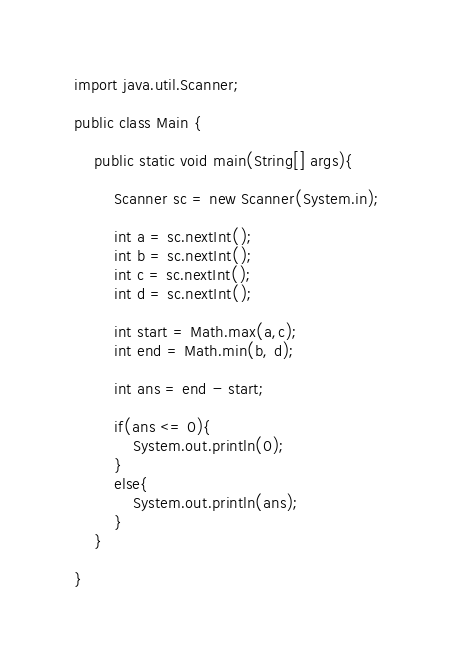Convert code to text. <code><loc_0><loc_0><loc_500><loc_500><_Java_>import java.util.Scanner;

public class Main {

	public static void main(String[] args){
		
		Scanner sc = new Scanner(System.in);
		
		int a = sc.nextInt();
		int b = sc.nextInt();
		int c = sc.nextInt();
		int d = sc.nextInt();
		
		int start = Math.max(a,c);
		int end = Math.min(b, d);
		
		int ans = end - start;
		
		if(ans <= 0){
			System.out.println(0);
		}
		else{
			System.out.println(ans);
		}
	}

}</code> 